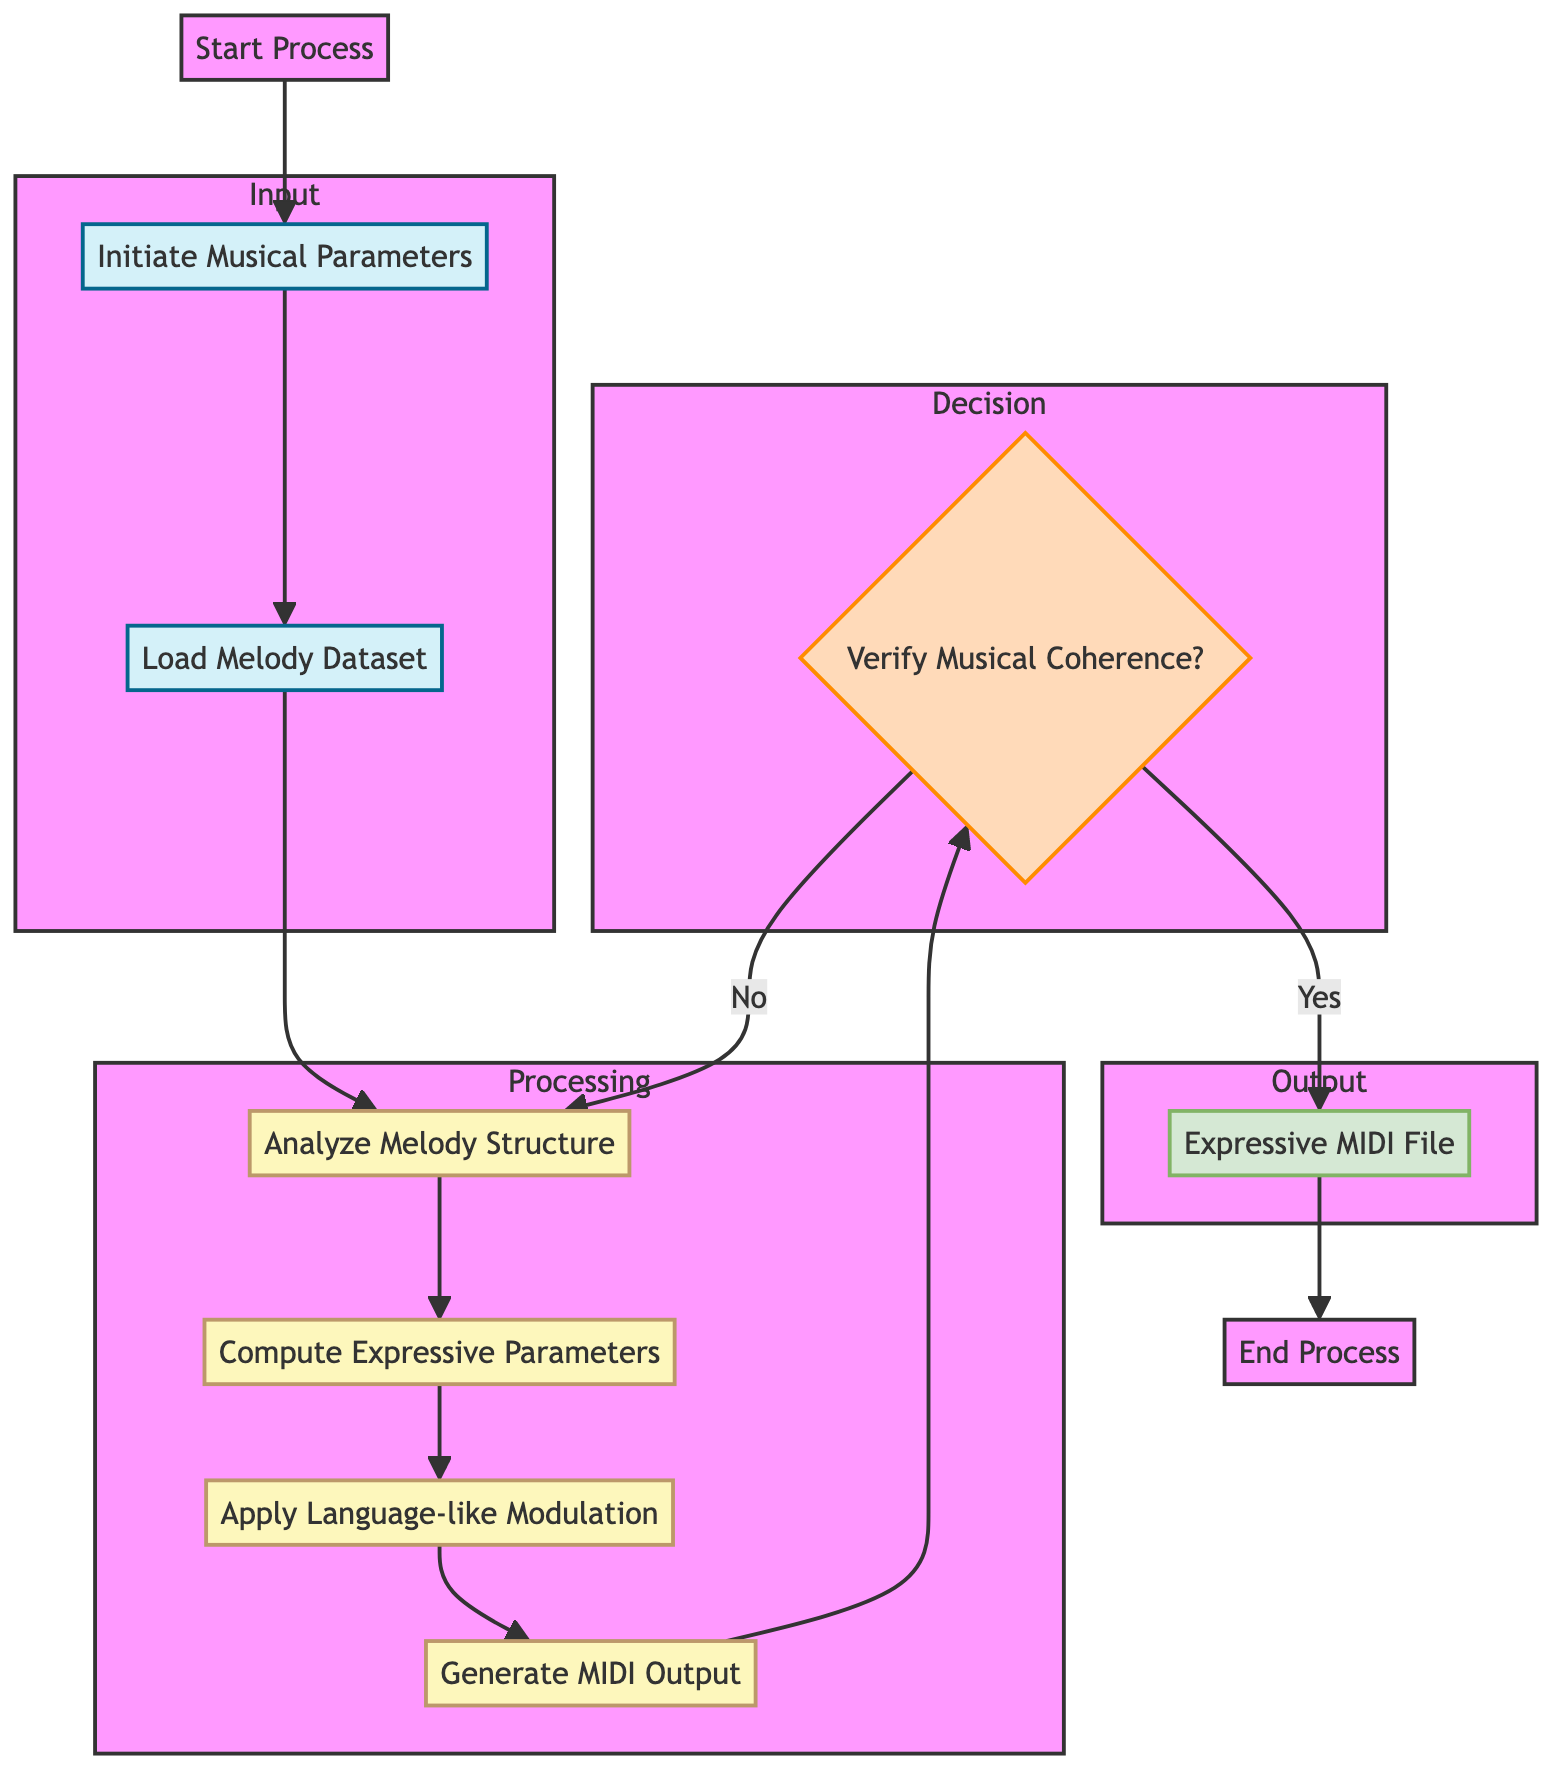What starts the process in this flowchart? The flowchart begins with the "Start Process" node, which initiates the entire sequence of steps in the diagram.
Answer: Start Process How many processing steps are there? There are four processing steps in the flowchart: Analyze Melody Structure, Compute Expressive Parameters, Apply Language-like Modulation, and Generate MIDI Output. Counting these, the total is four.
Answer: 4 What is the output of the process? The final output of the flowchart is represented by the "Expressive MIDI File" node, which signifies the completion of the process.
Answer: Expressive MIDI File Which step follows the analysis of melody structure? After the "Analyze Melody Structure" step, the next step is "Compute Expressive Parameters," which continues the overall processing of the music automation task.
Answer: Compute Expressive Parameters What happens if the musical coherence is not verified? If musical coherence is not verified, the flowchart indicates a cycle back to the "Analyze Melody Structure" step, allowing for re-evaluation and adjustments to the melody.
Answer: Analyze Melody Structure How many input nodes are there in the flowchart? The flowchart contains two input nodes: "Initiate Musical Parameters" and "Load Melody Dataset," representing the initial information needed for the process.
Answer: 2 Explain the relationship between generating MIDI output and verifying musical coherence. After the step "Generate MIDI Output," the flowchart has a decision node "Verify Musical Coherence?" This indicates that the MIDI output needs to be checked for coherence as part of the quality assurance before finalizing the output.
Answer: Decision node What are the parameters being initiated in the first step? In the first step, "Initiate Musical Parameters," the parameters are "Key Signature," "Tempo," and "Dynamics," indicating the musical framework for the generation of expressive phrases.
Answer: Key Signature, Tempo, Dynamics 